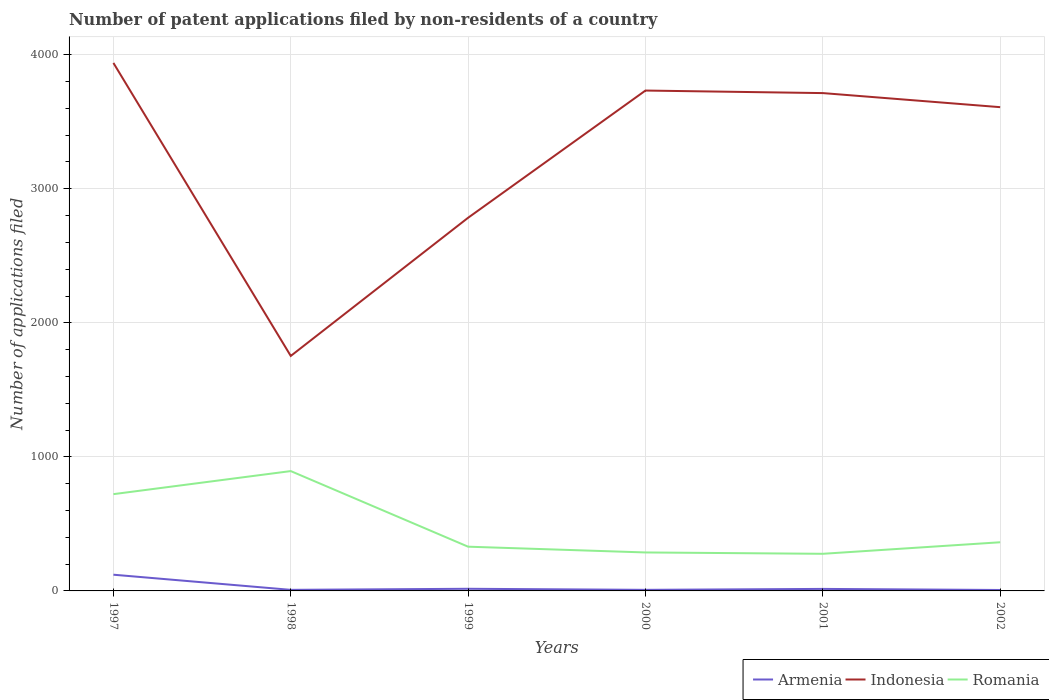Does the line corresponding to Indonesia intersect with the line corresponding to Romania?
Ensure brevity in your answer.  No. Across all years, what is the maximum number of applications filed in Romania?
Provide a succinct answer. 277. In which year was the number of applications filed in Armenia maximum?
Give a very brief answer. 2002. What is the total number of applications filed in Romania in the graph?
Offer a terse response. 359. What is the difference between the highest and the second highest number of applications filed in Romania?
Provide a short and direct response. 617. Is the number of applications filed in Armenia strictly greater than the number of applications filed in Indonesia over the years?
Provide a short and direct response. Yes. How many years are there in the graph?
Your response must be concise. 6. What is the difference between two consecutive major ticks on the Y-axis?
Give a very brief answer. 1000. Does the graph contain any zero values?
Your response must be concise. No. Does the graph contain grids?
Ensure brevity in your answer.  Yes. Where does the legend appear in the graph?
Make the answer very short. Bottom right. How many legend labels are there?
Your answer should be very brief. 3. How are the legend labels stacked?
Give a very brief answer. Horizontal. What is the title of the graph?
Make the answer very short. Number of patent applications filed by non-residents of a country. Does "Samoa" appear as one of the legend labels in the graph?
Offer a very short reply. No. What is the label or title of the Y-axis?
Your answer should be compact. Number of applications filed. What is the Number of applications filed in Armenia in 1997?
Your answer should be very brief. 121. What is the Number of applications filed in Indonesia in 1997?
Your answer should be compact. 3939. What is the Number of applications filed of Romania in 1997?
Provide a short and direct response. 722. What is the Number of applications filed in Armenia in 1998?
Give a very brief answer. 8. What is the Number of applications filed of Indonesia in 1998?
Your answer should be very brief. 1753. What is the Number of applications filed of Romania in 1998?
Make the answer very short. 894. What is the Number of applications filed of Indonesia in 1999?
Your answer should be very brief. 2784. What is the Number of applications filed in Romania in 1999?
Offer a terse response. 330. What is the Number of applications filed of Indonesia in 2000?
Ensure brevity in your answer.  3733. What is the Number of applications filed in Romania in 2000?
Your answer should be compact. 287. What is the Number of applications filed in Armenia in 2001?
Ensure brevity in your answer.  15. What is the Number of applications filed in Indonesia in 2001?
Your answer should be very brief. 3714. What is the Number of applications filed in Romania in 2001?
Offer a very short reply. 277. What is the Number of applications filed in Armenia in 2002?
Your answer should be compact. 7. What is the Number of applications filed in Indonesia in 2002?
Ensure brevity in your answer.  3609. What is the Number of applications filed in Romania in 2002?
Ensure brevity in your answer.  363. Across all years, what is the maximum Number of applications filed in Armenia?
Keep it short and to the point. 121. Across all years, what is the maximum Number of applications filed in Indonesia?
Offer a very short reply. 3939. Across all years, what is the maximum Number of applications filed in Romania?
Provide a succinct answer. 894. Across all years, what is the minimum Number of applications filed in Indonesia?
Make the answer very short. 1753. Across all years, what is the minimum Number of applications filed in Romania?
Offer a terse response. 277. What is the total Number of applications filed of Armenia in the graph?
Make the answer very short. 175. What is the total Number of applications filed in Indonesia in the graph?
Offer a very short reply. 1.95e+04. What is the total Number of applications filed in Romania in the graph?
Offer a very short reply. 2873. What is the difference between the Number of applications filed of Armenia in 1997 and that in 1998?
Provide a short and direct response. 113. What is the difference between the Number of applications filed in Indonesia in 1997 and that in 1998?
Ensure brevity in your answer.  2186. What is the difference between the Number of applications filed of Romania in 1997 and that in 1998?
Your answer should be compact. -172. What is the difference between the Number of applications filed of Armenia in 1997 and that in 1999?
Make the answer very short. 105. What is the difference between the Number of applications filed of Indonesia in 1997 and that in 1999?
Your answer should be very brief. 1155. What is the difference between the Number of applications filed of Romania in 1997 and that in 1999?
Your answer should be compact. 392. What is the difference between the Number of applications filed of Armenia in 1997 and that in 2000?
Ensure brevity in your answer.  113. What is the difference between the Number of applications filed of Indonesia in 1997 and that in 2000?
Keep it short and to the point. 206. What is the difference between the Number of applications filed of Romania in 1997 and that in 2000?
Offer a very short reply. 435. What is the difference between the Number of applications filed of Armenia in 1997 and that in 2001?
Offer a very short reply. 106. What is the difference between the Number of applications filed of Indonesia in 1997 and that in 2001?
Your answer should be very brief. 225. What is the difference between the Number of applications filed in Romania in 1997 and that in 2001?
Give a very brief answer. 445. What is the difference between the Number of applications filed of Armenia in 1997 and that in 2002?
Give a very brief answer. 114. What is the difference between the Number of applications filed in Indonesia in 1997 and that in 2002?
Give a very brief answer. 330. What is the difference between the Number of applications filed of Romania in 1997 and that in 2002?
Ensure brevity in your answer.  359. What is the difference between the Number of applications filed in Armenia in 1998 and that in 1999?
Keep it short and to the point. -8. What is the difference between the Number of applications filed in Indonesia in 1998 and that in 1999?
Your answer should be compact. -1031. What is the difference between the Number of applications filed of Romania in 1998 and that in 1999?
Provide a succinct answer. 564. What is the difference between the Number of applications filed of Armenia in 1998 and that in 2000?
Ensure brevity in your answer.  0. What is the difference between the Number of applications filed in Indonesia in 1998 and that in 2000?
Keep it short and to the point. -1980. What is the difference between the Number of applications filed of Romania in 1998 and that in 2000?
Ensure brevity in your answer.  607. What is the difference between the Number of applications filed in Armenia in 1998 and that in 2001?
Ensure brevity in your answer.  -7. What is the difference between the Number of applications filed of Indonesia in 1998 and that in 2001?
Provide a succinct answer. -1961. What is the difference between the Number of applications filed of Romania in 1998 and that in 2001?
Your answer should be very brief. 617. What is the difference between the Number of applications filed of Indonesia in 1998 and that in 2002?
Ensure brevity in your answer.  -1856. What is the difference between the Number of applications filed of Romania in 1998 and that in 2002?
Make the answer very short. 531. What is the difference between the Number of applications filed of Armenia in 1999 and that in 2000?
Your answer should be very brief. 8. What is the difference between the Number of applications filed of Indonesia in 1999 and that in 2000?
Provide a short and direct response. -949. What is the difference between the Number of applications filed of Armenia in 1999 and that in 2001?
Ensure brevity in your answer.  1. What is the difference between the Number of applications filed in Indonesia in 1999 and that in 2001?
Your answer should be compact. -930. What is the difference between the Number of applications filed of Indonesia in 1999 and that in 2002?
Make the answer very short. -825. What is the difference between the Number of applications filed in Romania in 1999 and that in 2002?
Provide a short and direct response. -33. What is the difference between the Number of applications filed in Indonesia in 2000 and that in 2001?
Your response must be concise. 19. What is the difference between the Number of applications filed of Romania in 2000 and that in 2001?
Give a very brief answer. 10. What is the difference between the Number of applications filed in Indonesia in 2000 and that in 2002?
Keep it short and to the point. 124. What is the difference between the Number of applications filed of Romania in 2000 and that in 2002?
Provide a short and direct response. -76. What is the difference between the Number of applications filed in Armenia in 2001 and that in 2002?
Your answer should be very brief. 8. What is the difference between the Number of applications filed of Indonesia in 2001 and that in 2002?
Provide a short and direct response. 105. What is the difference between the Number of applications filed of Romania in 2001 and that in 2002?
Your answer should be compact. -86. What is the difference between the Number of applications filed in Armenia in 1997 and the Number of applications filed in Indonesia in 1998?
Your response must be concise. -1632. What is the difference between the Number of applications filed in Armenia in 1997 and the Number of applications filed in Romania in 1998?
Ensure brevity in your answer.  -773. What is the difference between the Number of applications filed of Indonesia in 1997 and the Number of applications filed of Romania in 1998?
Keep it short and to the point. 3045. What is the difference between the Number of applications filed in Armenia in 1997 and the Number of applications filed in Indonesia in 1999?
Ensure brevity in your answer.  -2663. What is the difference between the Number of applications filed of Armenia in 1997 and the Number of applications filed of Romania in 1999?
Give a very brief answer. -209. What is the difference between the Number of applications filed of Indonesia in 1997 and the Number of applications filed of Romania in 1999?
Provide a succinct answer. 3609. What is the difference between the Number of applications filed in Armenia in 1997 and the Number of applications filed in Indonesia in 2000?
Give a very brief answer. -3612. What is the difference between the Number of applications filed of Armenia in 1997 and the Number of applications filed of Romania in 2000?
Offer a very short reply. -166. What is the difference between the Number of applications filed of Indonesia in 1997 and the Number of applications filed of Romania in 2000?
Your response must be concise. 3652. What is the difference between the Number of applications filed in Armenia in 1997 and the Number of applications filed in Indonesia in 2001?
Give a very brief answer. -3593. What is the difference between the Number of applications filed in Armenia in 1997 and the Number of applications filed in Romania in 2001?
Make the answer very short. -156. What is the difference between the Number of applications filed in Indonesia in 1997 and the Number of applications filed in Romania in 2001?
Offer a very short reply. 3662. What is the difference between the Number of applications filed of Armenia in 1997 and the Number of applications filed of Indonesia in 2002?
Provide a short and direct response. -3488. What is the difference between the Number of applications filed of Armenia in 1997 and the Number of applications filed of Romania in 2002?
Provide a short and direct response. -242. What is the difference between the Number of applications filed of Indonesia in 1997 and the Number of applications filed of Romania in 2002?
Your response must be concise. 3576. What is the difference between the Number of applications filed of Armenia in 1998 and the Number of applications filed of Indonesia in 1999?
Offer a very short reply. -2776. What is the difference between the Number of applications filed in Armenia in 1998 and the Number of applications filed in Romania in 1999?
Ensure brevity in your answer.  -322. What is the difference between the Number of applications filed of Indonesia in 1998 and the Number of applications filed of Romania in 1999?
Provide a succinct answer. 1423. What is the difference between the Number of applications filed in Armenia in 1998 and the Number of applications filed in Indonesia in 2000?
Offer a terse response. -3725. What is the difference between the Number of applications filed of Armenia in 1998 and the Number of applications filed of Romania in 2000?
Make the answer very short. -279. What is the difference between the Number of applications filed of Indonesia in 1998 and the Number of applications filed of Romania in 2000?
Your answer should be very brief. 1466. What is the difference between the Number of applications filed of Armenia in 1998 and the Number of applications filed of Indonesia in 2001?
Ensure brevity in your answer.  -3706. What is the difference between the Number of applications filed in Armenia in 1998 and the Number of applications filed in Romania in 2001?
Your response must be concise. -269. What is the difference between the Number of applications filed of Indonesia in 1998 and the Number of applications filed of Romania in 2001?
Offer a very short reply. 1476. What is the difference between the Number of applications filed in Armenia in 1998 and the Number of applications filed in Indonesia in 2002?
Offer a terse response. -3601. What is the difference between the Number of applications filed of Armenia in 1998 and the Number of applications filed of Romania in 2002?
Provide a short and direct response. -355. What is the difference between the Number of applications filed in Indonesia in 1998 and the Number of applications filed in Romania in 2002?
Offer a very short reply. 1390. What is the difference between the Number of applications filed in Armenia in 1999 and the Number of applications filed in Indonesia in 2000?
Your answer should be compact. -3717. What is the difference between the Number of applications filed of Armenia in 1999 and the Number of applications filed of Romania in 2000?
Provide a short and direct response. -271. What is the difference between the Number of applications filed in Indonesia in 1999 and the Number of applications filed in Romania in 2000?
Your answer should be compact. 2497. What is the difference between the Number of applications filed in Armenia in 1999 and the Number of applications filed in Indonesia in 2001?
Your answer should be compact. -3698. What is the difference between the Number of applications filed of Armenia in 1999 and the Number of applications filed of Romania in 2001?
Provide a short and direct response. -261. What is the difference between the Number of applications filed in Indonesia in 1999 and the Number of applications filed in Romania in 2001?
Make the answer very short. 2507. What is the difference between the Number of applications filed in Armenia in 1999 and the Number of applications filed in Indonesia in 2002?
Provide a succinct answer. -3593. What is the difference between the Number of applications filed in Armenia in 1999 and the Number of applications filed in Romania in 2002?
Offer a very short reply. -347. What is the difference between the Number of applications filed of Indonesia in 1999 and the Number of applications filed of Romania in 2002?
Provide a succinct answer. 2421. What is the difference between the Number of applications filed in Armenia in 2000 and the Number of applications filed in Indonesia in 2001?
Offer a terse response. -3706. What is the difference between the Number of applications filed of Armenia in 2000 and the Number of applications filed of Romania in 2001?
Ensure brevity in your answer.  -269. What is the difference between the Number of applications filed in Indonesia in 2000 and the Number of applications filed in Romania in 2001?
Ensure brevity in your answer.  3456. What is the difference between the Number of applications filed of Armenia in 2000 and the Number of applications filed of Indonesia in 2002?
Your response must be concise. -3601. What is the difference between the Number of applications filed in Armenia in 2000 and the Number of applications filed in Romania in 2002?
Offer a very short reply. -355. What is the difference between the Number of applications filed of Indonesia in 2000 and the Number of applications filed of Romania in 2002?
Provide a short and direct response. 3370. What is the difference between the Number of applications filed of Armenia in 2001 and the Number of applications filed of Indonesia in 2002?
Give a very brief answer. -3594. What is the difference between the Number of applications filed of Armenia in 2001 and the Number of applications filed of Romania in 2002?
Make the answer very short. -348. What is the difference between the Number of applications filed of Indonesia in 2001 and the Number of applications filed of Romania in 2002?
Ensure brevity in your answer.  3351. What is the average Number of applications filed in Armenia per year?
Your response must be concise. 29.17. What is the average Number of applications filed of Indonesia per year?
Provide a short and direct response. 3255.33. What is the average Number of applications filed in Romania per year?
Give a very brief answer. 478.83. In the year 1997, what is the difference between the Number of applications filed in Armenia and Number of applications filed in Indonesia?
Offer a very short reply. -3818. In the year 1997, what is the difference between the Number of applications filed of Armenia and Number of applications filed of Romania?
Provide a succinct answer. -601. In the year 1997, what is the difference between the Number of applications filed in Indonesia and Number of applications filed in Romania?
Your answer should be compact. 3217. In the year 1998, what is the difference between the Number of applications filed of Armenia and Number of applications filed of Indonesia?
Offer a very short reply. -1745. In the year 1998, what is the difference between the Number of applications filed in Armenia and Number of applications filed in Romania?
Offer a terse response. -886. In the year 1998, what is the difference between the Number of applications filed of Indonesia and Number of applications filed of Romania?
Your answer should be very brief. 859. In the year 1999, what is the difference between the Number of applications filed of Armenia and Number of applications filed of Indonesia?
Provide a succinct answer. -2768. In the year 1999, what is the difference between the Number of applications filed in Armenia and Number of applications filed in Romania?
Offer a terse response. -314. In the year 1999, what is the difference between the Number of applications filed of Indonesia and Number of applications filed of Romania?
Make the answer very short. 2454. In the year 2000, what is the difference between the Number of applications filed of Armenia and Number of applications filed of Indonesia?
Offer a terse response. -3725. In the year 2000, what is the difference between the Number of applications filed in Armenia and Number of applications filed in Romania?
Make the answer very short. -279. In the year 2000, what is the difference between the Number of applications filed of Indonesia and Number of applications filed of Romania?
Make the answer very short. 3446. In the year 2001, what is the difference between the Number of applications filed in Armenia and Number of applications filed in Indonesia?
Offer a very short reply. -3699. In the year 2001, what is the difference between the Number of applications filed of Armenia and Number of applications filed of Romania?
Provide a short and direct response. -262. In the year 2001, what is the difference between the Number of applications filed in Indonesia and Number of applications filed in Romania?
Your answer should be very brief. 3437. In the year 2002, what is the difference between the Number of applications filed of Armenia and Number of applications filed of Indonesia?
Ensure brevity in your answer.  -3602. In the year 2002, what is the difference between the Number of applications filed of Armenia and Number of applications filed of Romania?
Provide a succinct answer. -356. In the year 2002, what is the difference between the Number of applications filed in Indonesia and Number of applications filed in Romania?
Ensure brevity in your answer.  3246. What is the ratio of the Number of applications filed in Armenia in 1997 to that in 1998?
Give a very brief answer. 15.12. What is the ratio of the Number of applications filed in Indonesia in 1997 to that in 1998?
Provide a succinct answer. 2.25. What is the ratio of the Number of applications filed in Romania in 1997 to that in 1998?
Make the answer very short. 0.81. What is the ratio of the Number of applications filed in Armenia in 1997 to that in 1999?
Your answer should be very brief. 7.56. What is the ratio of the Number of applications filed in Indonesia in 1997 to that in 1999?
Provide a succinct answer. 1.41. What is the ratio of the Number of applications filed in Romania in 1997 to that in 1999?
Offer a very short reply. 2.19. What is the ratio of the Number of applications filed in Armenia in 1997 to that in 2000?
Ensure brevity in your answer.  15.12. What is the ratio of the Number of applications filed in Indonesia in 1997 to that in 2000?
Keep it short and to the point. 1.06. What is the ratio of the Number of applications filed in Romania in 1997 to that in 2000?
Provide a succinct answer. 2.52. What is the ratio of the Number of applications filed of Armenia in 1997 to that in 2001?
Your answer should be compact. 8.07. What is the ratio of the Number of applications filed in Indonesia in 1997 to that in 2001?
Your answer should be very brief. 1.06. What is the ratio of the Number of applications filed in Romania in 1997 to that in 2001?
Provide a succinct answer. 2.61. What is the ratio of the Number of applications filed in Armenia in 1997 to that in 2002?
Keep it short and to the point. 17.29. What is the ratio of the Number of applications filed in Indonesia in 1997 to that in 2002?
Offer a terse response. 1.09. What is the ratio of the Number of applications filed in Romania in 1997 to that in 2002?
Make the answer very short. 1.99. What is the ratio of the Number of applications filed of Indonesia in 1998 to that in 1999?
Ensure brevity in your answer.  0.63. What is the ratio of the Number of applications filed of Romania in 1998 to that in 1999?
Ensure brevity in your answer.  2.71. What is the ratio of the Number of applications filed of Indonesia in 1998 to that in 2000?
Your answer should be compact. 0.47. What is the ratio of the Number of applications filed in Romania in 1998 to that in 2000?
Make the answer very short. 3.12. What is the ratio of the Number of applications filed of Armenia in 1998 to that in 2001?
Keep it short and to the point. 0.53. What is the ratio of the Number of applications filed in Indonesia in 1998 to that in 2001?
Your response must be concise. 0.47. What is the ratio of the Number of applications filed of Romania in 1998 to that in 2001?
Offer a very short reply. 3.23. What is the ratio of the Number of applications filed in Indonesia in 1998 to that in 2002?
Offer a terse response. 0.49. What is the ratio of the Number of applications filed in Romania in 1998 to that in 2002?
Your answer should be very brief. 2.46. What is the ratio of the Number of applications filed in Armenia in 1999 to that in 2000?
Your answer should be compact. 2. What is the ratio of the Number of applications filed of Indonesia in 1999 to that in 2000?
Offer a very short reply. 0.75. What is the ratio of the Number of applications filed of Romania in 1999 to that in 2000?
Your answer should be compact. 1.15. What is the ratio of the Number of applications filed of Armenia in 1999 to that in 2001?
Give a very brief answer. 1.07. What is the ratio of the Number of applications filed of Indonesia in 1999 to that in 2001?
Offer a terse response. 0.75. What is the ratio of the Number of applications filed in Romania in 1999 to that in 2001?
Offer a very short reply. 1.19. What is the ratio of the Number of applications filed in Armenia in 1999 to that in 2002?
Ensure brevity in your answer.  2.29. What is the ratio of the Number of applications filed in Indonesia in 1999 to that in 2002?
Make the answer very short. 0.77. What is the ratio of the Number of applications filed in Armenia in 2000 to that in 2001?
Offer a terse response. 0.53. What is the ratio of the Number of applications filed of Romania in 2000 to that in 2001?
Your answer should be compact. 1.04. What is the ratio of the Number of applications filed in Armenia in 2000 to that in 2002?
Offer a terse response. 1.14. What is the ratio of the Number of applications filed in Indonesia in 2000 to that in 2002?
Make the answer very short. 1.03. What is the ratio of the Number of applications filed of Romania in 2000 to that in 2002?
Provide a succinct answer. 0.79. What is the ratio of the Number of applications filed of Armenia in 2001 to that in 2002?
Ensure brevity in your answer.  2.14. What is the ratio of the Number of applications filed in Indonesia in 2001 to that in 2002?
Provide a short and direct response. 1.03. What is the ratio of the Number of applications filed of Romania in 2001 to that in 2002?
Offer a very short reply. 0.76. What is the difference between the highest and the second highest Number of applications filed in Armenia?
Your answer should be compact. 105. What is the difference between the highest and the second highest Number of applications filed of Indonesia?
Provide a succinct answer. 206. What is the difference between the highest and the second highest Number of applications filed of Romania?
Make the answer very short. 172. What is the difference between the highest and the lowest Number of applications filed of Armenia?
Keep it short and to the point. 114. What is the difference between the highest and the lowest Number of applications filed in Indonesia?
Give a very brief answer. 2186. What is the difference between the highest and the lowest Number of applications filed of Romania?
Offer a terse response. 617. 